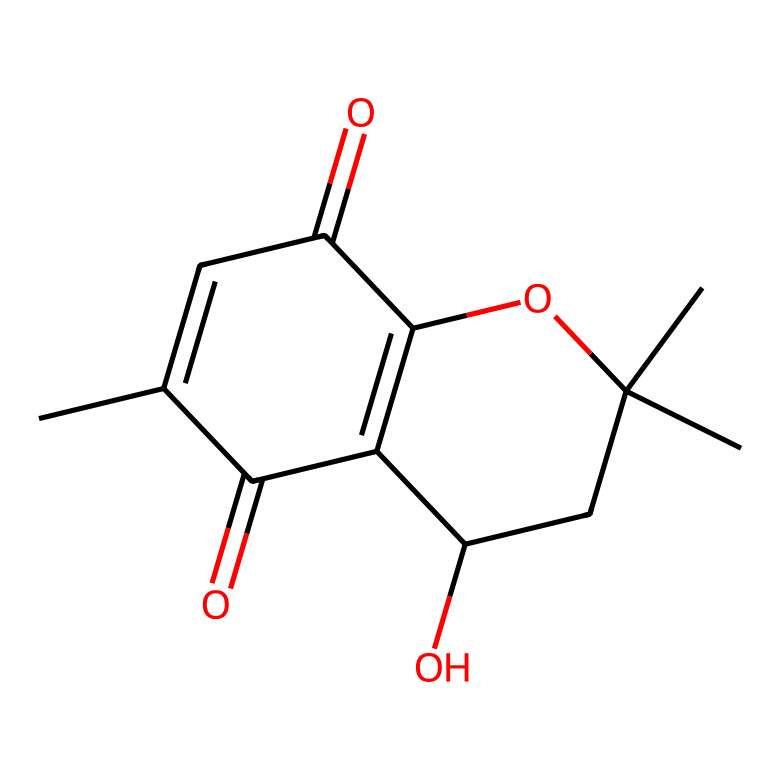What is the molecular formula of this compound? To find the molecular formula, count the number of each type of atom present in the SMILES notation. Analyzing the structure reveals there are 15 carbons, 16 hydrogens, and 5 oxygens, leading to the molecular formula C15H16O5.
Answer: C15H16O5 How many rings are present in this chemical structure? By examining the SMILES representation, the numbering indicates two fused ring structures, which confirms the presence of two rings in the compound.
Answer: 2 What functional groups can you identify in this compound? Looking at the structure, there are hydroxyl (-OH) groups and a carbonyl (C=O) group present, indicating the presence of alcohols and ketones as functional groups in the compound.
Answer: hydroxy and carbonyl Does this compound have chiral centers? By examining the structural information for asymmetrical carbon atoms, I can see that there are two chiral centers due to the presence of carbon atoms bonded to four different atoms/groups.
Answer: 2 How does the structure inform its application as a calming agent? The presence of certain functional groups, particularly the phenolic structure and hydroxyl groups, suggests potential interactions with neurotransmitters, contributing to its calming effects, therefore supporting its use in calming teas.
Answer: calming agent What is the solubility characteristic of this compound? Non-Newtonian fluids generally change viscosity in response to stress; hereby, the presence of multiple polar functional groups suggests this compound is likely to be soluble in water, making it suitable for infusion in teas.
Answer: soluble in water 